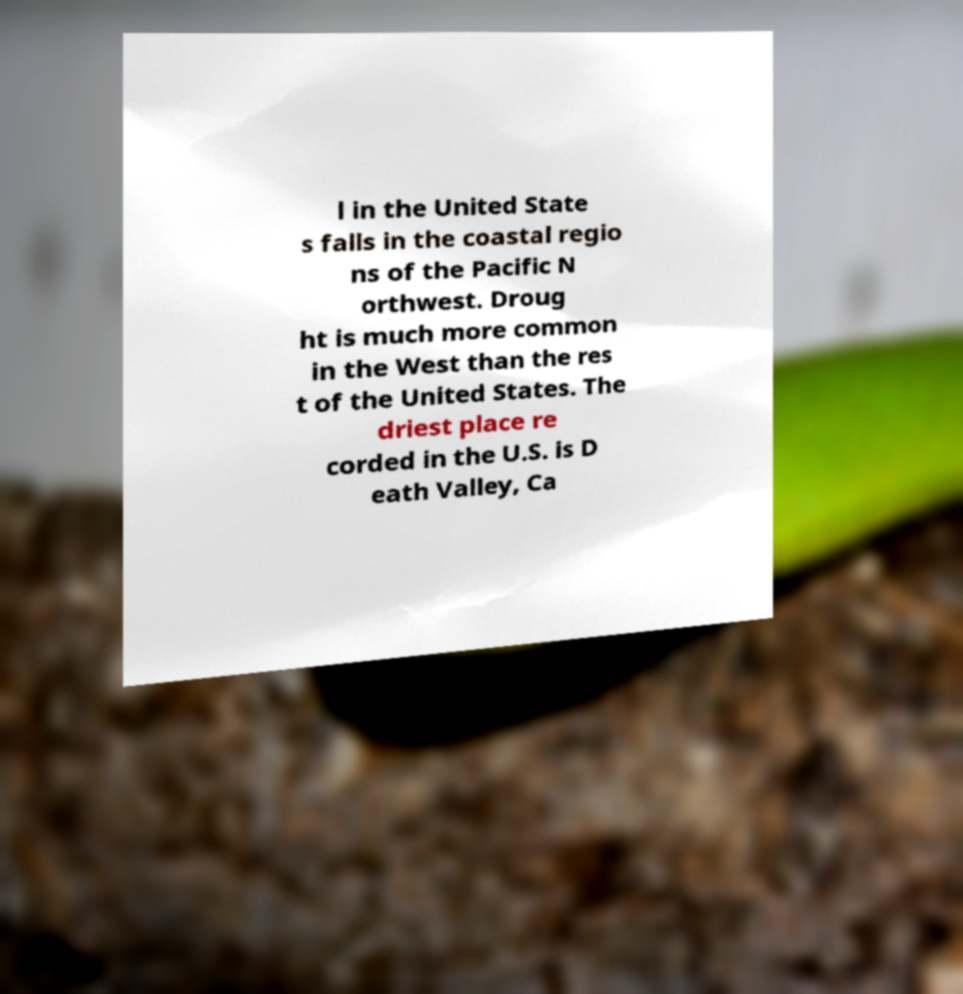For documentation purposes, I need the text within this image transcribed. Could you provide that? l in the United State s falls in the coastal regio ns of the Pacific N orthwest. Droug ht is much more common in the West than the res t of the United States. The driest place re corded in the U.S. is D eath Valley, Ca 